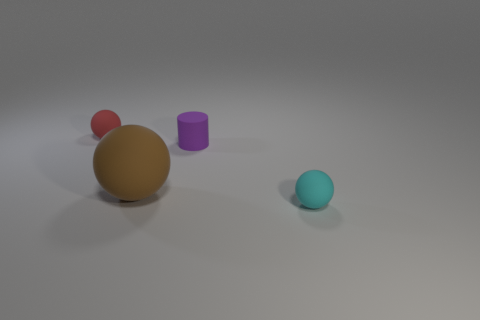How many objects are small things or balls?
Give a very brief answer. 4. What number of big things are red things or balls?
Offer a terse response. 1. Is there any other thing that has the same color as the large object?
Keep it short and to the point. No. There is a thing that is both in front of the red thing and left of the tiny purple object; what is its size?
Keep it short and to the point. Large. What number of other objects are there of the same material as the tiny purple cylinder?
Provide a succinct answer. 3. What shape is the object that is to the left of the tiny rubber cylinder and behind the large brown rubber thing?
Provide a short and direct response. Sphere. There is a matte sphere to the right of the cylinder; does it have the same size as the purple thing?
Your response must be concise. Yes. There is another large object that is the same shape as the cyan rubber object; what is its material?
Offer a very short reply. Rubber. Is the shape of the tiny cyan rubber thing the same as the small red thing?
Your response must be concise. Yes. There is a tiny rubber ball to the right of the small red matte sphere; what number of large brown matte balls are to the right of it?
Your response must be concise. 0. 